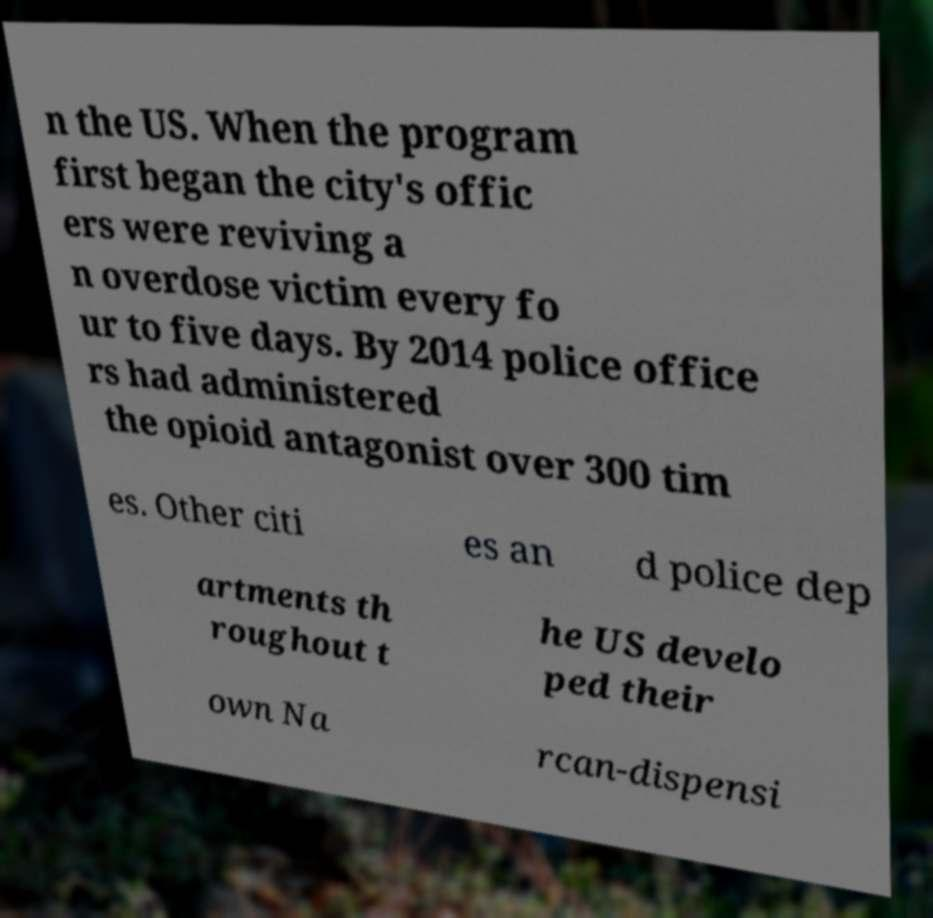Can you accurately transcribe the text from the provided image for me? n the US. When the program first began the city's offic ers were reviving a n overdose victim every fo ur to five days. By 2014 police office rs had administered the opioid antagonist over 300 tim es. Other citi es an d police dep artments th roughout t he US develo ped their own Na rcan-dispensi 